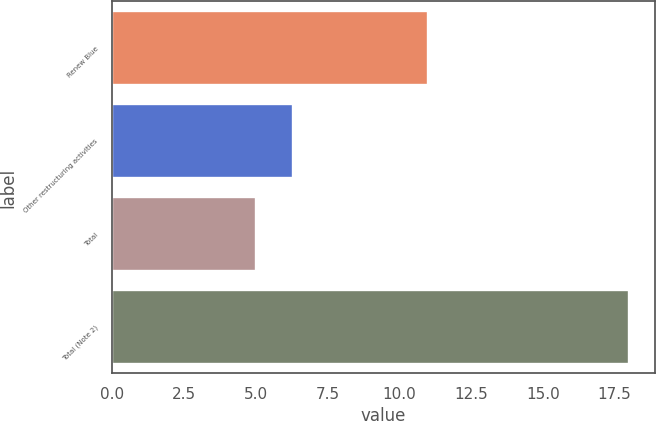<chart> <loc_0><loc_0><loc_500><loc_500><bar_chart><fcel>Renew Blue<fcel>Other restructuring activities<fcel>Total<fcel>Total (Note 2)<nl><fcel>11<fcel>6.3<fcel>5<fcel>18<nl></chart> 